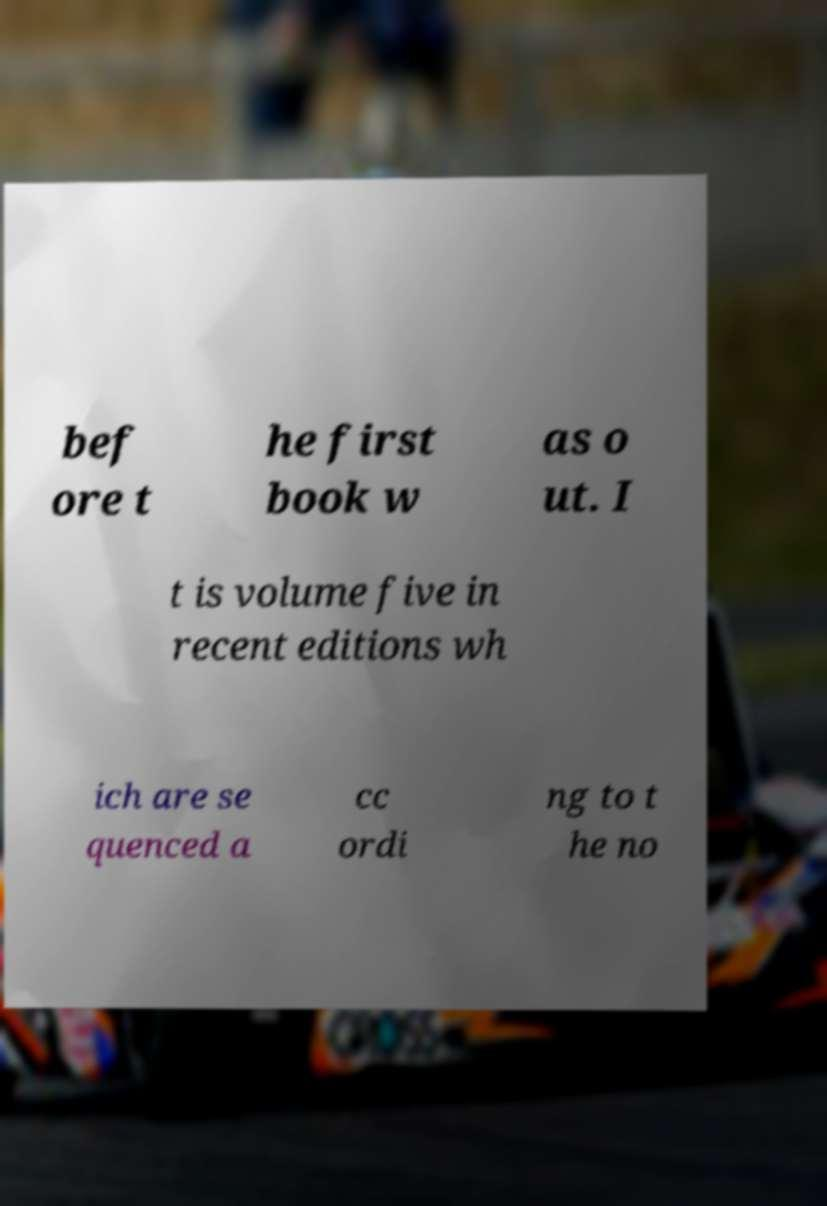Can you read and provide the text displayed in the image?This photo seems to have some interesting text. Can you extract and type it out for me? bef ore t he first book w as o ut. I t is volume five in recent editions wh ich are se quenced a cc ordi ng to t he no 